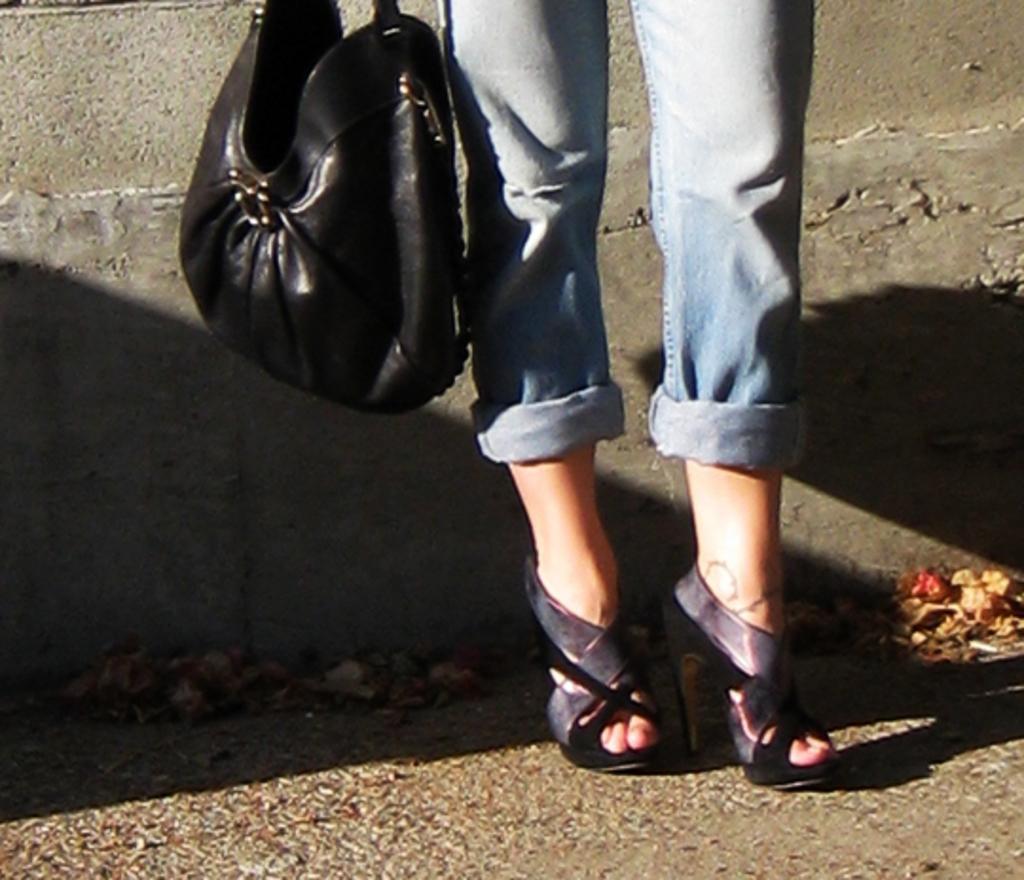How would you summarize this image in a sentence or two? In this picture there are legs of a girl wearing high heels and a black bag beside her. The picture is taken in a daylight. 